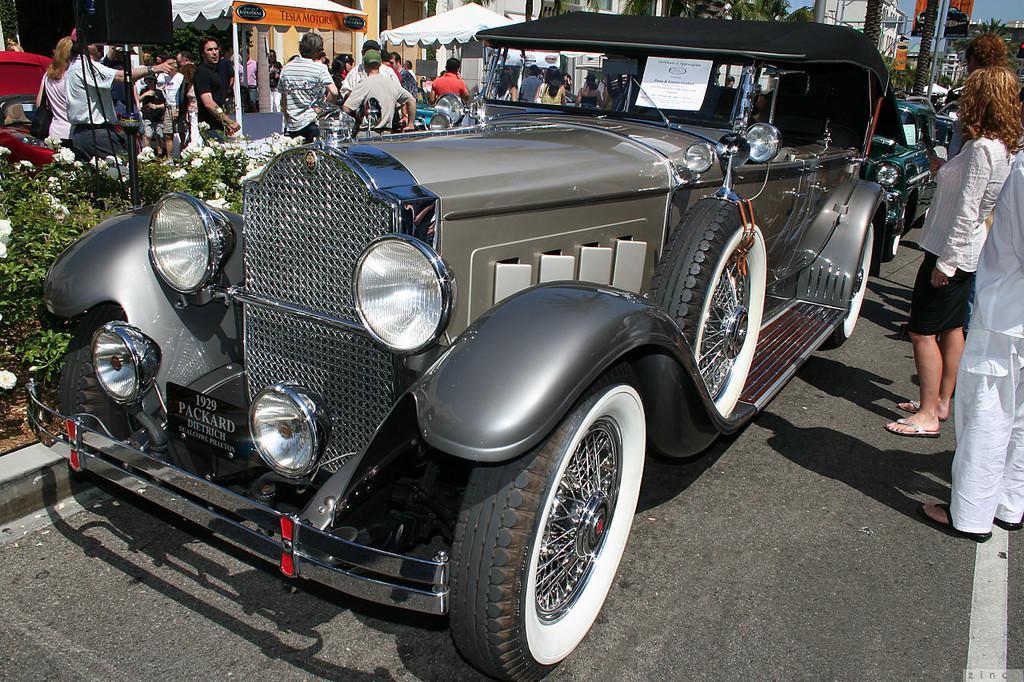Describe this image in one or two sentences. In this picture we can see a vehicle on the path. We can see few people are standing on the path. There are some flowers and plants on the path. We can see few stalls, trees, buildings and some boards on the pole. 